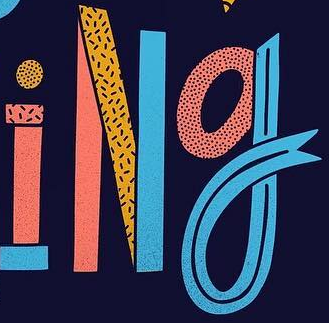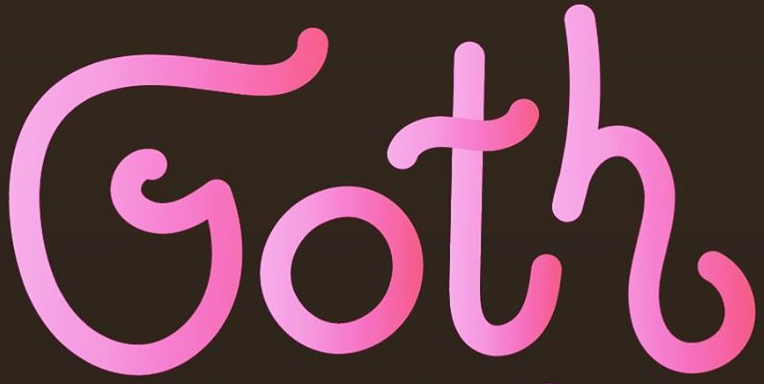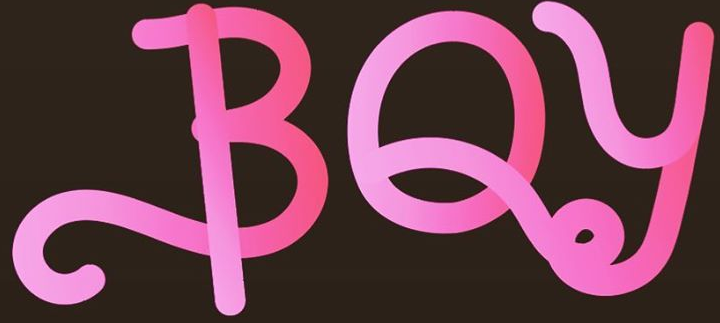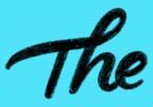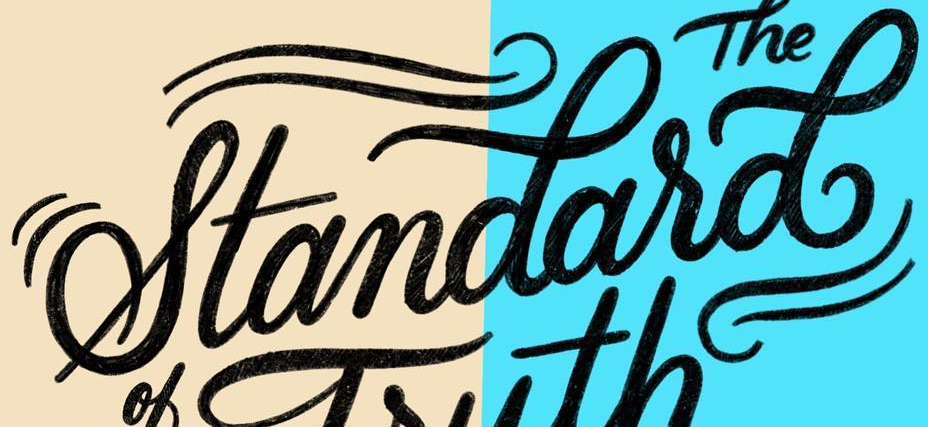Read the text content from these images in order, separated by a semicolon. iNg; Goth; BOy; The; standasd 